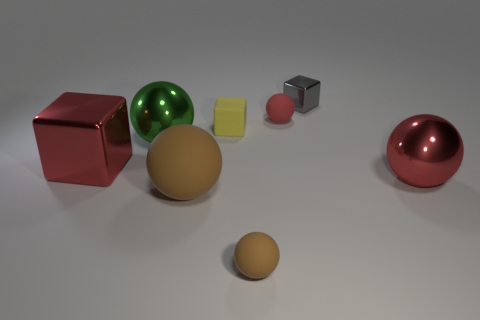Is the number of tiny metallic cubes less than the number of purple cubes?
Your answer should be compact. No. Is there a shiny object in front of the yellow rubber cube behind the red metal object left of the green metallic object?
Make the answer very short. Yes. How many metallic things are spheres or cyan objects?
Provide a succinct answer. 2. Is the color of the small metal block the same as the big cube?
Keep it short and to the point. No. There is a big red metal ball; what number of gray metal cubes are behind it?
Keep it short and to the point. 1. What number of cubes are both to the left of the small gray metal block and behind the yellow block?
Ensure brevity in your answer.  0. The gray object that is made of the same material as the big block is what shape?
Offer a terse response. Cube. There is a red ball that is behind the matte block; is its size the same as the metal block that is behind the large red block?
Offer a very short reply. Yes. What color is the tiny rubber ball that is behind the red shiny block?
Your response must be concise. Red. The large red object that is right of the small yellow object that is on the right side of the large brown thing is made of what material?
Your answer should be very brief. Metal. 